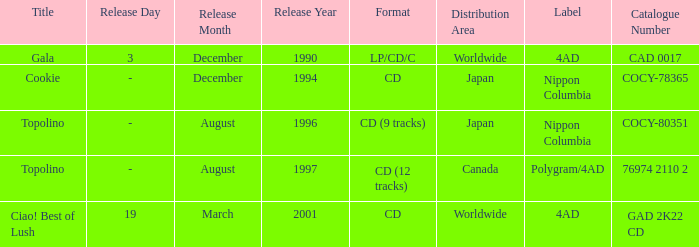What Label released an album in August 1996? Nippon Columbia. 